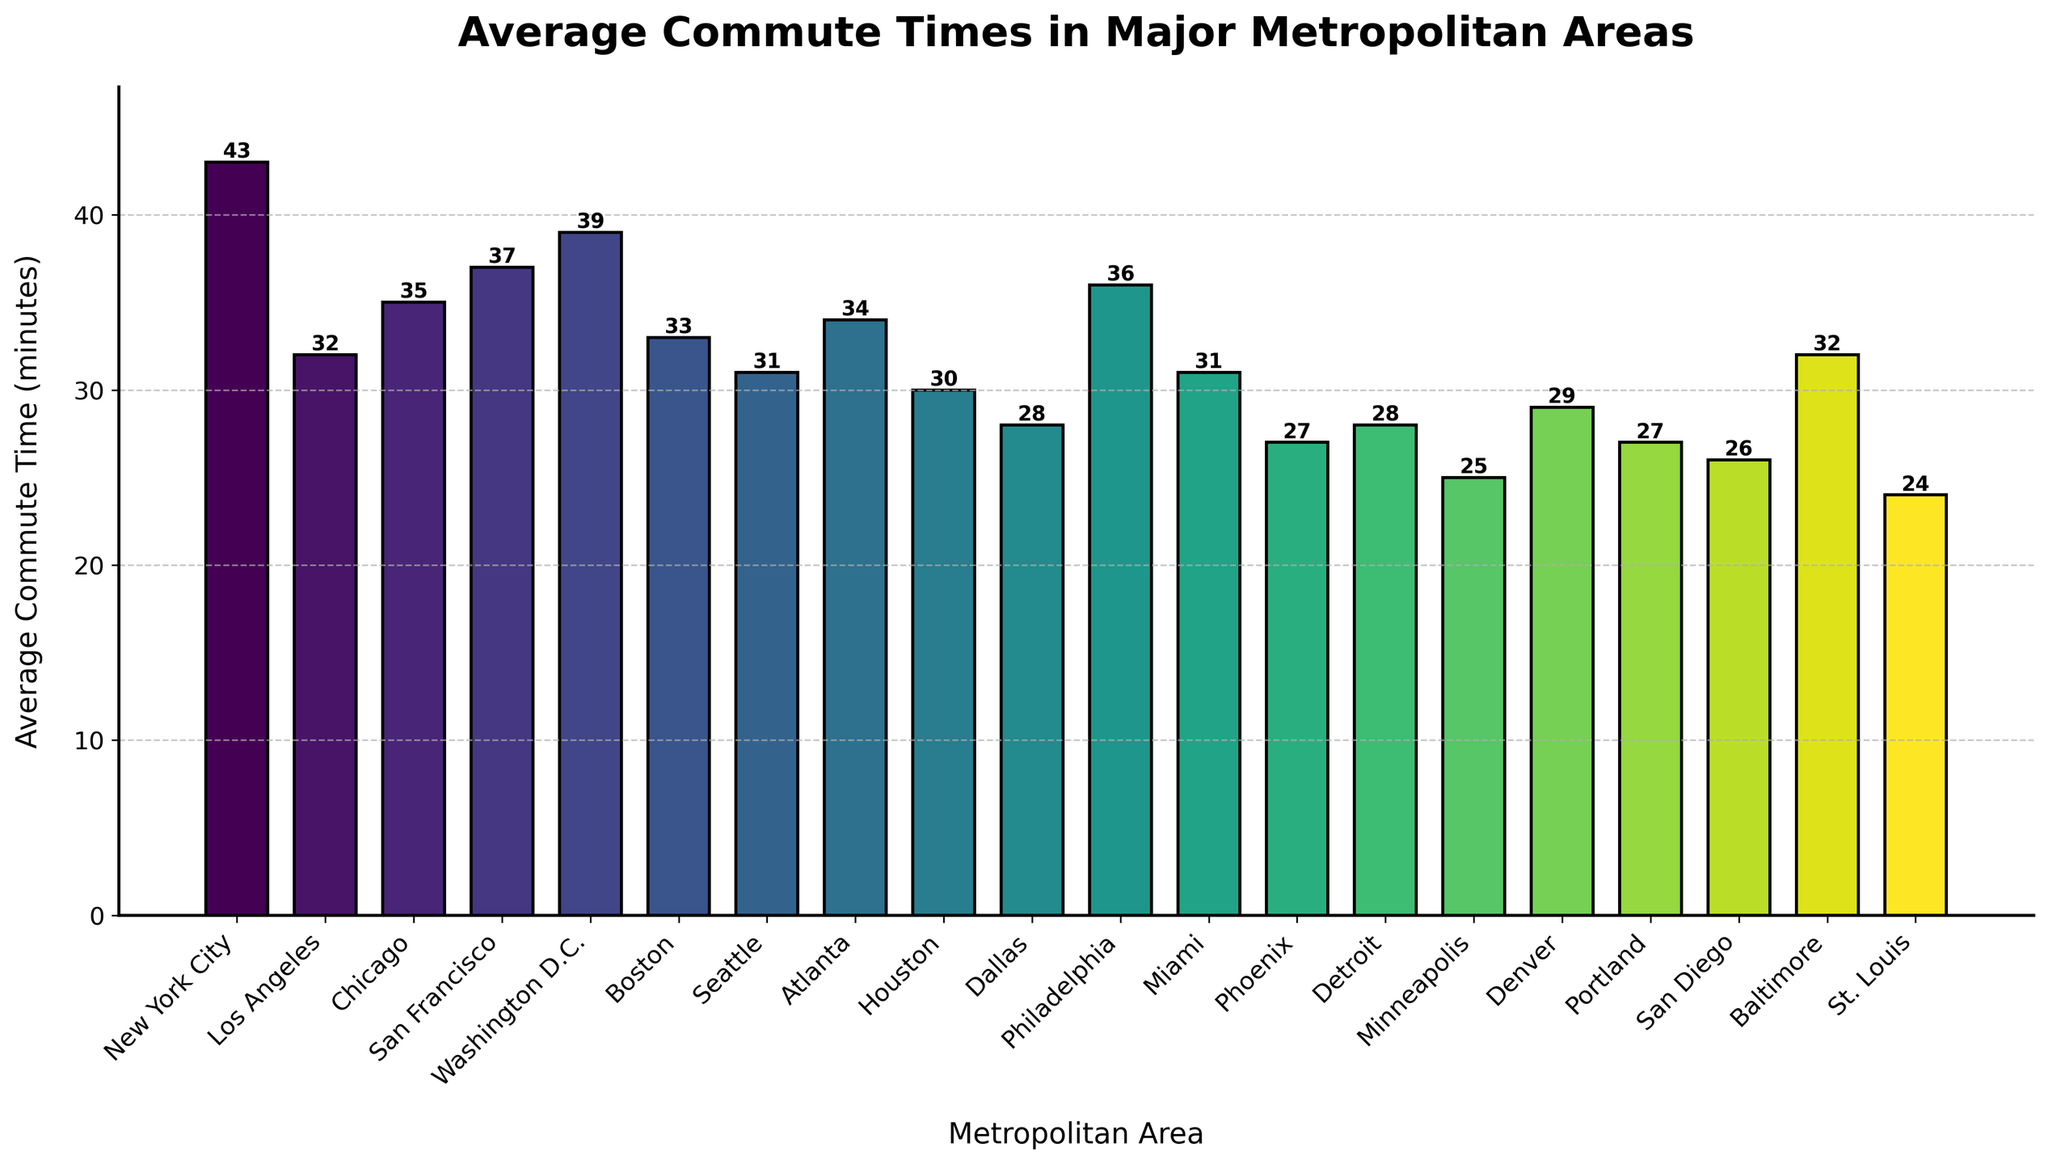Which metropolitan area has the longest average commute time? The longest average commute time is indicated by the tallest bar on the chart. New York City is the metro area with the tallest bar.
Answer: New York City Which metropolitan area has a shorter average commute time: Dallas or Detroit? Compare the heights of the bars for Dallas and Detroit. The bar for Dallas is shorter than the bar for Detroit, indicating a shorter average commute time.
Answer: Dallas What is the difference in average commute times between New York City and St. Louis? Find the heights of the bars for New York City and St. Louis. Subtract the height of the bar for St. Louis from the height of the bar for New York City: 43 - 24 = 19.
Answer: 19 minutes How many metropolitan areas have an average commute time higher than 35 minutes? Count the number of bars that exceed the 35-minute mark. These are New York City, Chicago, San Francisco, Washington D.C., Philadelphia.
Answer: 5 Which has a larger average commute time, Boston or Baltimore? Compare the heights of the bars for Boston and Baltimore. Boston has a shorter height than Baltimore.
Answer: Baltimore What is the average commute time for the three areas with the shortest commutes? Identify the shortest bars: St. Louis (24), Minneapolis (25), San Diego (26). Calculate the average: (24 + 25 + 26) / 3 = 25.
Answer: 25 minutes Is there any metropolitan area on the chart with an average commute time equal to 30 minutes? Locate the bar with a height equal to 30 minutes. The metro area with a 30-minute commute time is Houston.
Answer: Houston What is the combined average commute time for Los Angeles and Miami? Look at the heights of the bars for Los Angeles (32) and Miami (31). Add them together: 32 + 31 = 63.
Answer: 63 minutes Which bar color represents the metropolitan area with the highest commute time, and what is that color? The bar representing New York City, which has the highest commute time, is the tallest and is colored in the gradient of the viridis colormap, which is one of the more intense color shades.
Answer: Intense viridis shade Are there more metro areas with an average commute time below 30 minutes or above 40 minutes? Count the bars below 30 minutes: Phoenix, Minneapolis, San Diego, Denver, Portland, St. Louis. Count the bars above 40 minutes: New York City. There are more bars below 30 minutes.
Answer: Below 30 minutes 